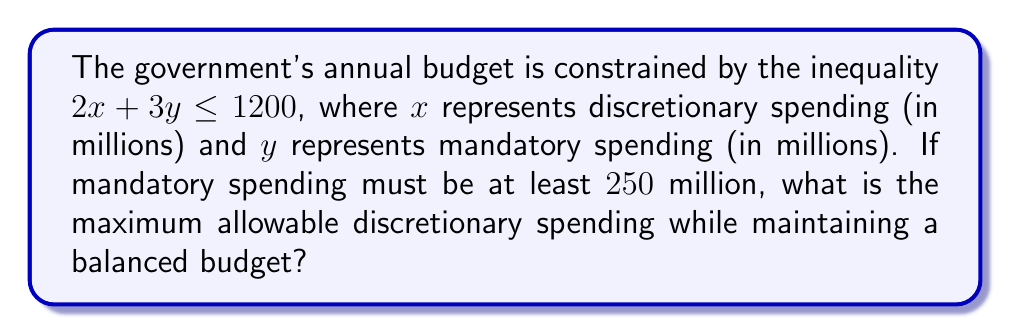Could you help me with this problem? 1) We start with the inequality representing the budget constraint:
   $$2x + 3y \leq 1200$$

2) We're told that mandatory spending ($y$) must be at least $250$ million:
   $$y \geq 250$$

3) To find the maximum allowable discretionary spending ($x$), we need to minimize $y$ while maximizing $x$. Therefore, we set $y = 250$.

4) Substituting this into our original inequality:
   $$2x + 3(250) \leq 1200$$

5) Simplify:
   $$2x + 750 \leq 1200$$

6) Subtract 750 from both sides:
   $$2x \leq 450$$

7) Divide both sides by 2:
   $$x \leq 225$$

8) Therefore, the maximum allowable discretionary spending is $225$ million.
Answer: $225$ million 